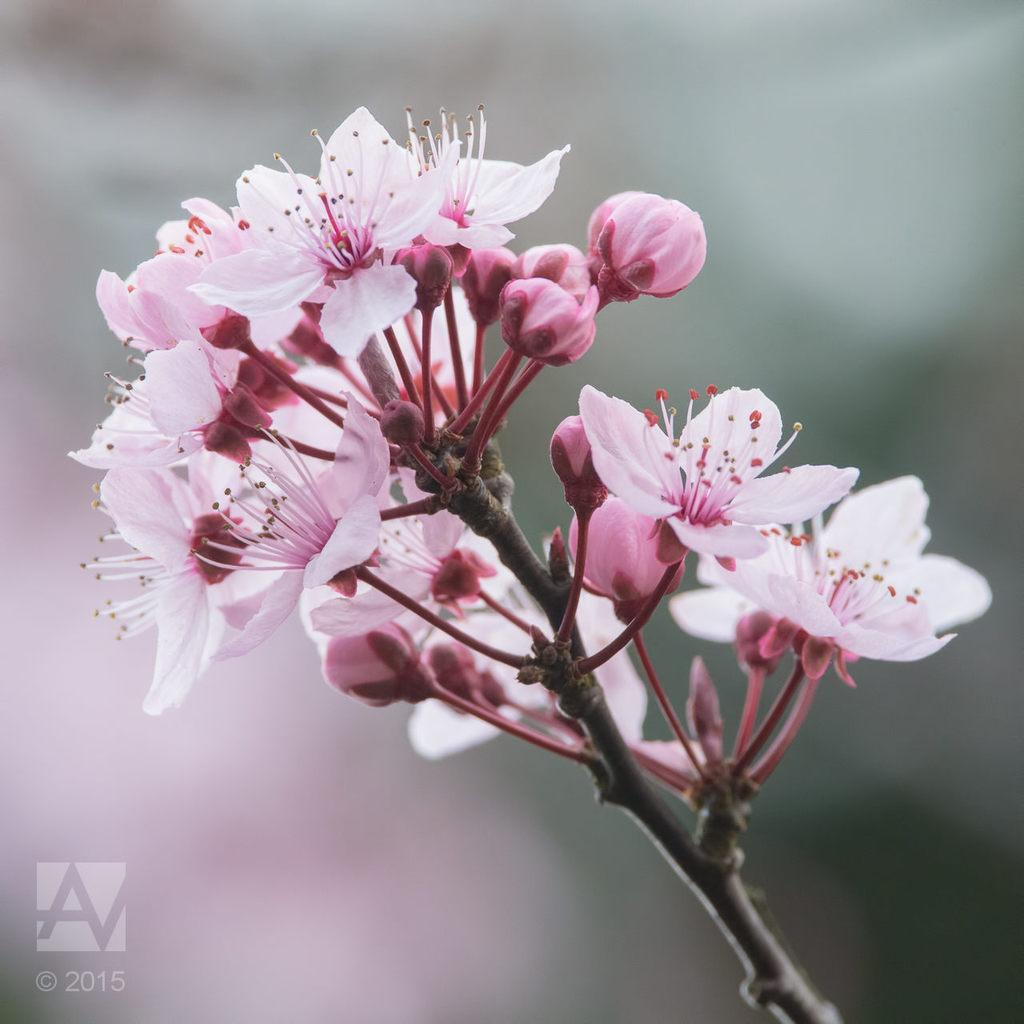What type of plant life is visible in the image? There are flowers and flower buds in the image. What color are the flowers in the image? The flowers are light pink in color. Where are the flowers located in the image? The flowers are on a branch. How would you describe the background of the image? The background of the image appears blurry. Is there any additional information or marking on the image? Yes, there is a watermark on the image. What type of design is featured on the airplane in the image? There is no airplane present in the image; it features flowers and flower buds on a branch. What hobbies do the flowers in the image enjoy? Flowers do not have hobbies, as they are inanimate objects. 